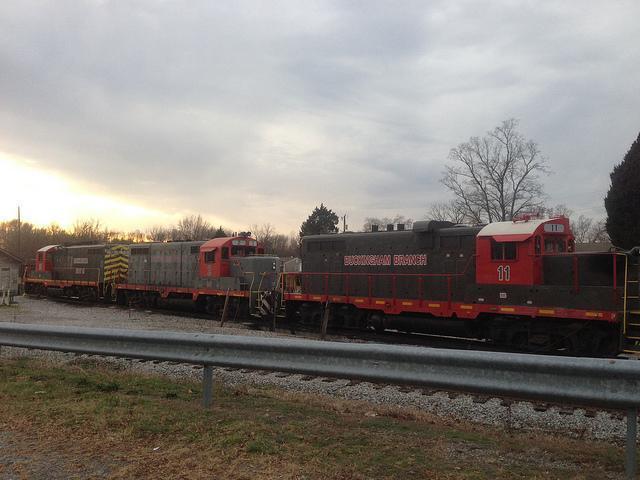How many train carts are there?
Give a very brief answer. 3. How many poles are there?
Give a very brief answer. 0. 